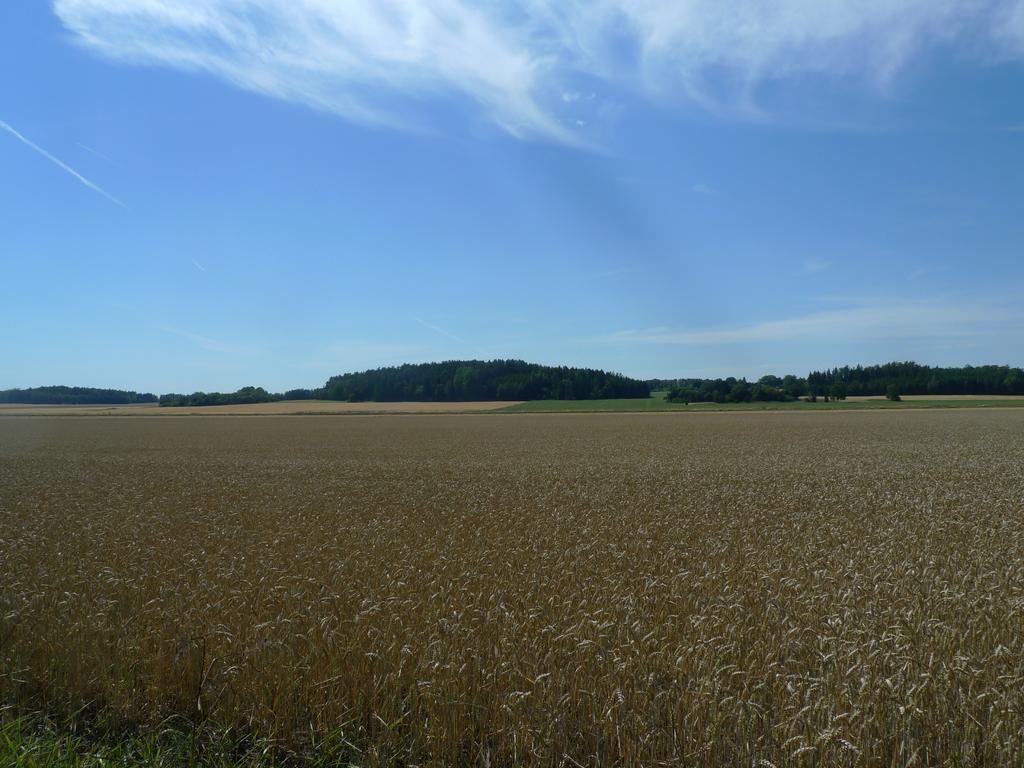Please provide a concise description of this image. In the image we can see there are plants on the ground and behind there are trees. There is clear sky on the top. 